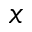Convert formula to latex. <formula><loc_0><loc_0><loc_500><loc_500>x</formula> 